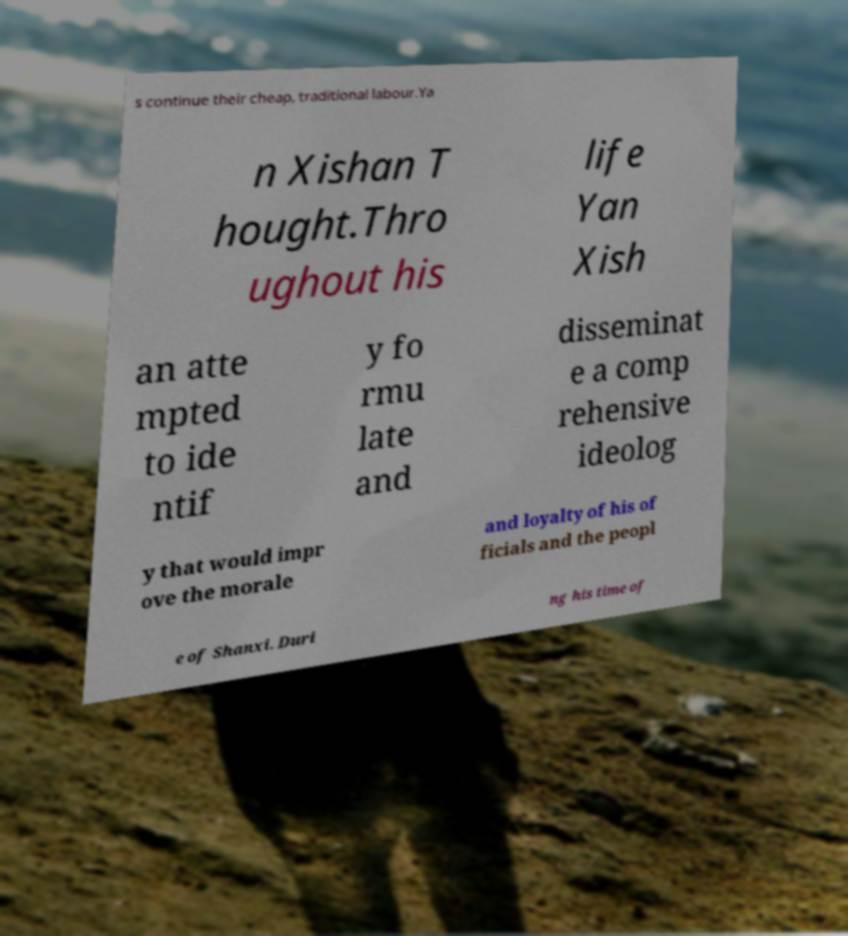Could you extract and type out the text from this image? s continue their cheap, traditional labour.Ya n Xishan T hought.Thro ughout his life Yan Xish an atte mpted to ide ntif y fo rmu late and disseminat e a comp rehensive ideolog y that would impr ove the morale and loyalty of his of ficials and the peopl e of Shanxi. Duri ng his time of 